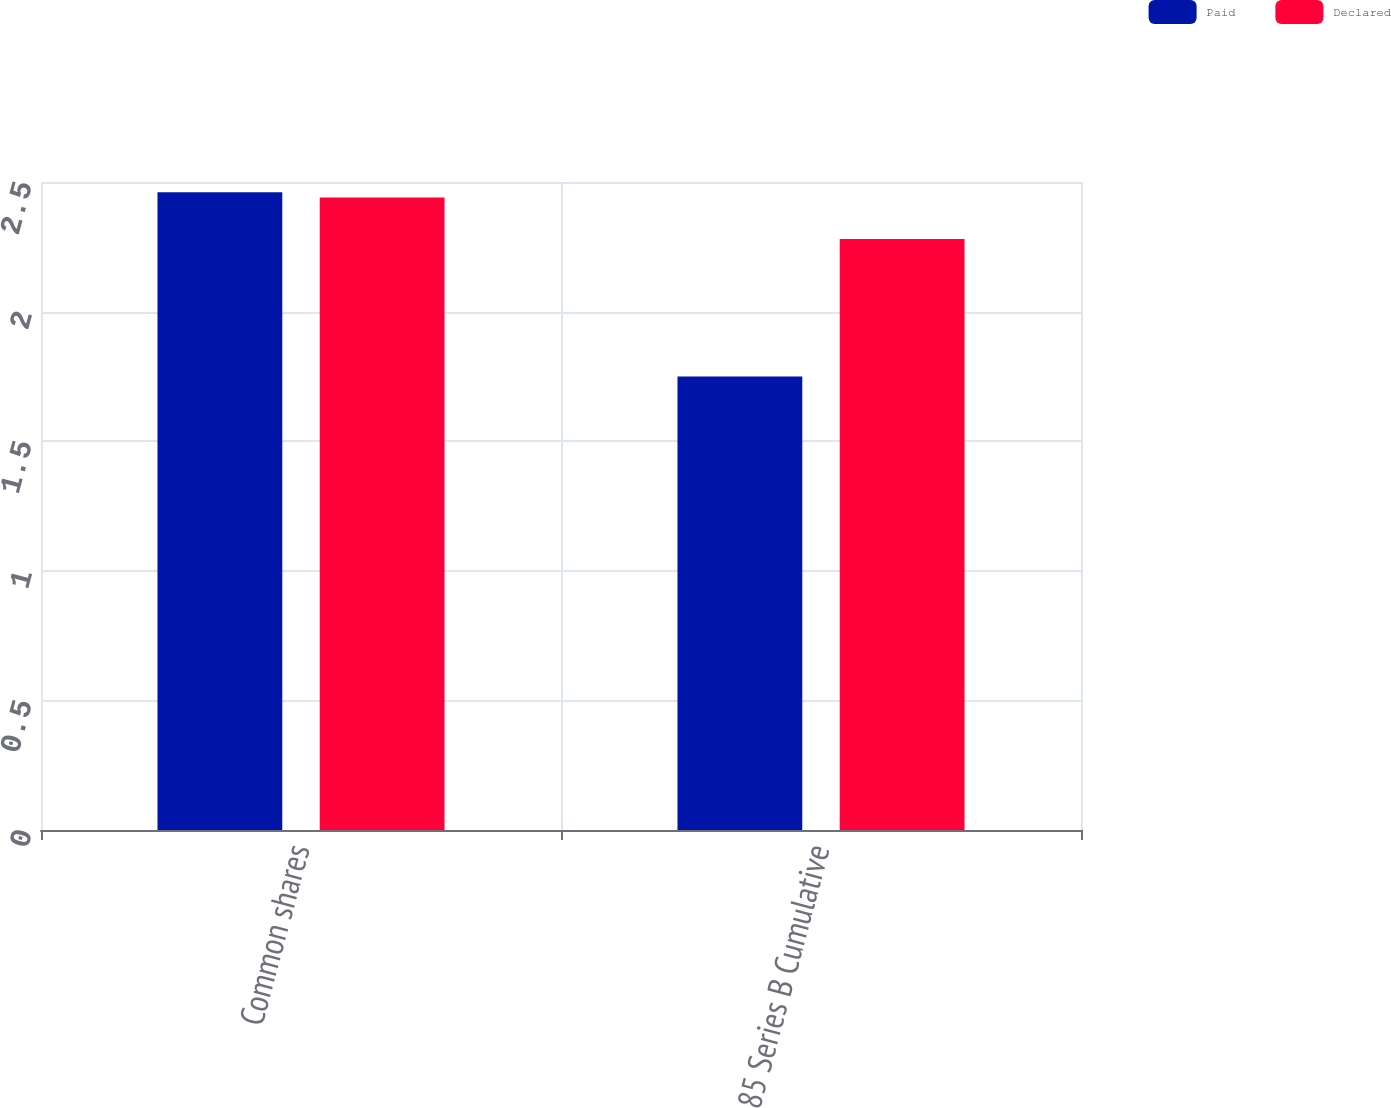Convert chart to OTSL. <chart><loc_0><loc_0><loc_500><loc_500><stacked_bar_chart><ecel><fcel>Common shares<fcel>85 Series B Cumulative<nl><fcel>Paid<fcel>2.46<fcel>1.75<nl><fcel>Declared<fcel>2.44<fcel>2.28<nl></chart> 